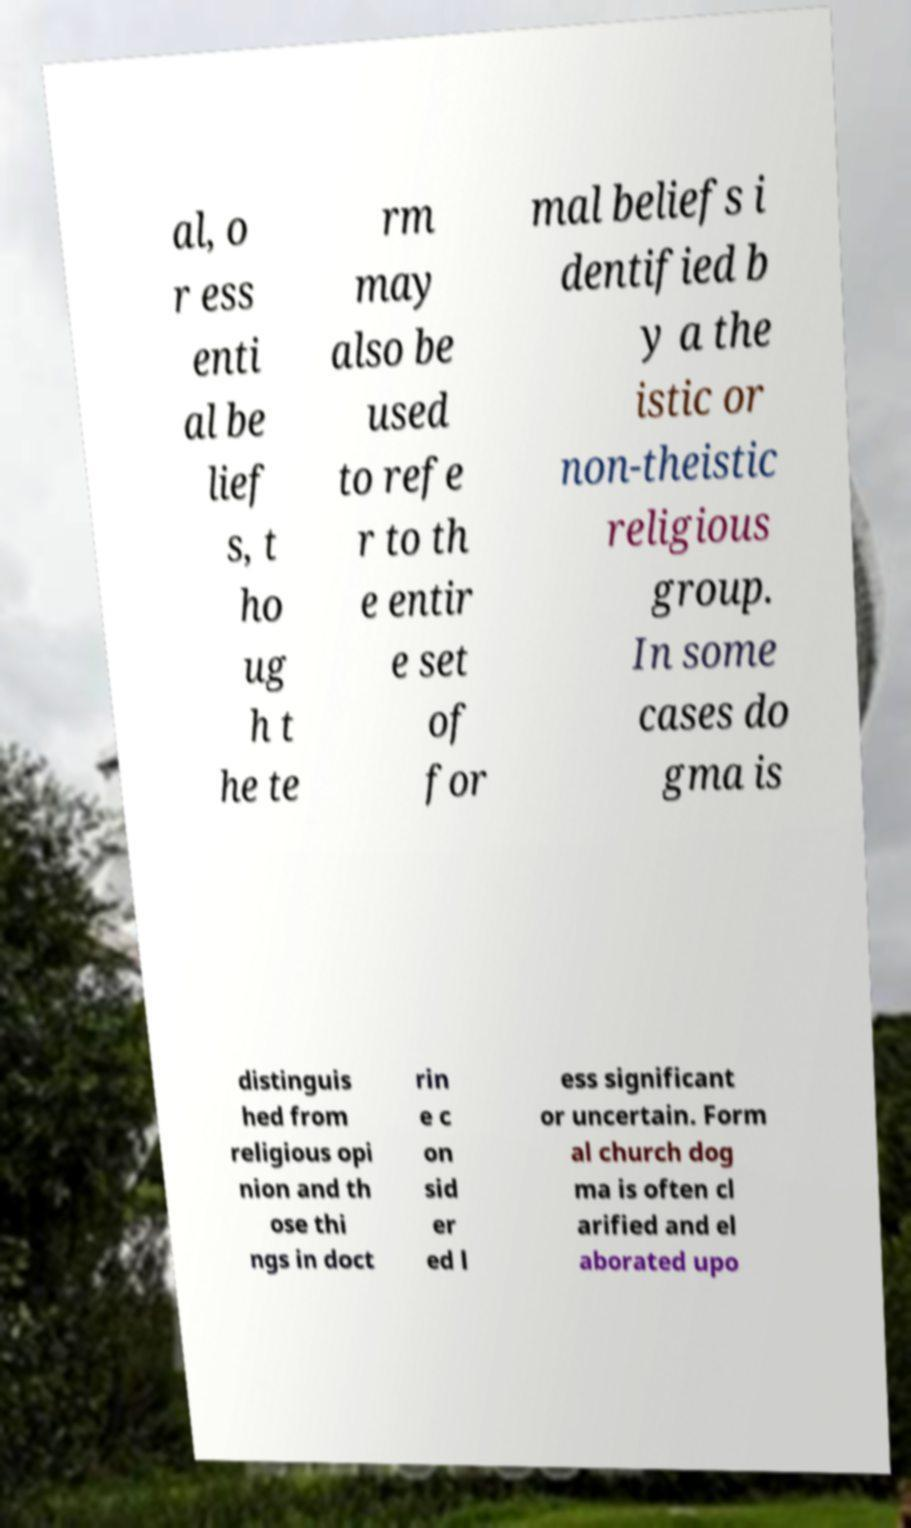I need the written content from this picture converted into text. Can you do that? al, o r ess enti al be lief s, t ho ug h t he te rm may also be used to refe r to th e entir e set of for mal beliefs i dentified b y a the istic or non-theistic religious group. In some cases do gma is distinguis hed from religious opi nion and th ose thi ngs in doct rin e c on sid er ed l ess significant or uncertain. Form al church dog ma is often cl arified and el aborated upo 